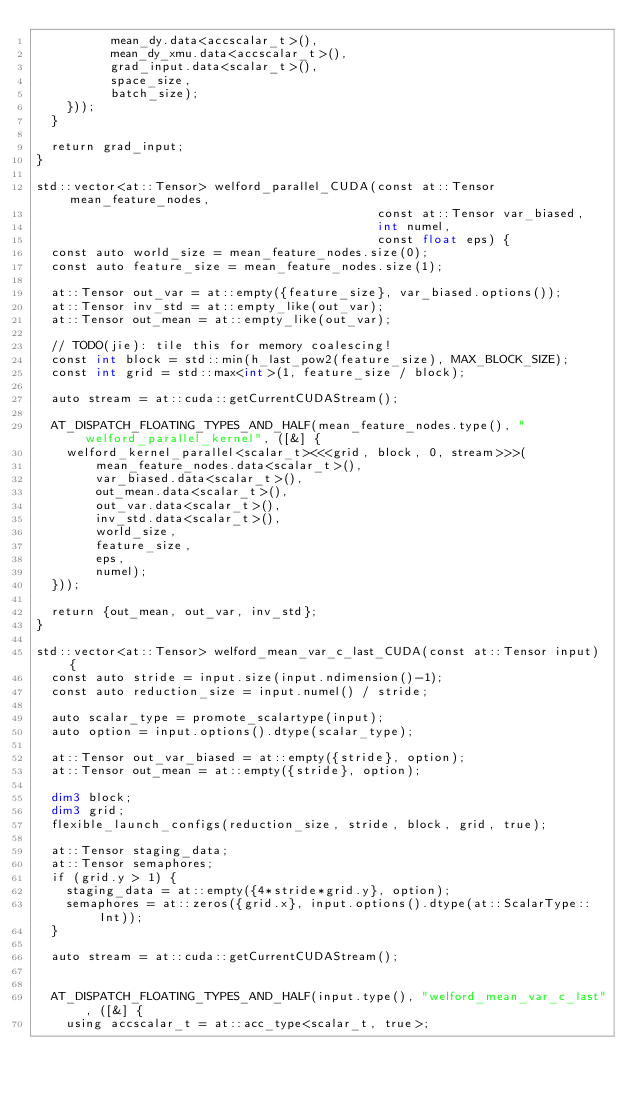Convert code to text. <code><loc_0><loc_0><loc_500><loc_500><_Cuda_>          mean_dy.data<accscalar_t>(),
          mean_dy_xmu.data<accscalar_t>(),
          grad_input.data<scalar_t>(),
          space_size,
          batch_size);
    }));
  }

  return grad_input;
}

std::vector<at::Tensor> welford_parallel_CUDA(const at::Tensor mean_feature_nodes,
                                              const at::Tensor var_biased,
                                              int numel,
                                              const float eps) {
  const auto world_size = mean_feature_nodes.size(0);
  const auto feature_size = mean_feature_nodes.size(1);

  at::Tensor out_var = at::empty({feature_size}, var_biased.options());
  at::Tensor inv_std = at::empty_like(out_var);
  at::Tensor out_mean = at::empty_like(out_var);

  // TODO(jie): tile this for memory coalescing!
  const int block = std::min(h_last_pow2(feature_size), MAX_BLOCK_SIZE);
  const int grid = std::max<int>(1, feature_size / block);

  auto stream = at::cuda::getCurrentCUDAStream();

  AT_DISPATCH_FLOATING_TYPES_AND_HALF(mean_feature_nodes.type(), "welford_parallel_kernel", ([&] {
    welford_kernel_parallel<scalar_t><<<grid, block, 0, stream>>>(
        mean_feature_nodes.data<scalar_t>(),
        var_biased.data<scalar_t>(),
        out_mean.data<scalar_t>(),
        out_var.data<scalar_t>(),
        inv_std.data<scalar_t>(),
        world_size,
        feature_size,
        eps,
        numel);
  }));

  return {out_mean, out_var, inv_std};
}

std::vector<at::Tensor> welford_mean_var_c_last_CUDA(const at::Tensor input) {
  const auto stride = input.size(input.ndimension()-1);
  const auto reduction_size = input.numel() / stride;

  auto scalar_type = promote_scalartype(input);
  auto option = input.options().dtype(scalar_type);

  at::Tensor out_var_biased = at::empty({stride}, option);
  at::Tensor out_mean = at::empty({stride}, option);

  dim3 block;
  dim3 grid;
  flexible_launch_configs(reduction_size, stride, block, grid, true);

  at::Tensor staging_data;
  at::Tensor semaphores;
  if (grid.y > 1) {
    staging_data = at::empty({4*stride*grid.y}, option);
    semaphores = at::zeros({grid.x}, input.options().dtype(at::ScalarType::Int));
  }

  auto stream = at::cuda::getCurrentCUDAStream();


  AT_DISPATCH_FLOATING_TYPES_AND_HALF(input.type(), "welford_mean_var_c_last", ([&] {
    using accscalar_t = at::acc_type<scalar_t, true>;</code> 